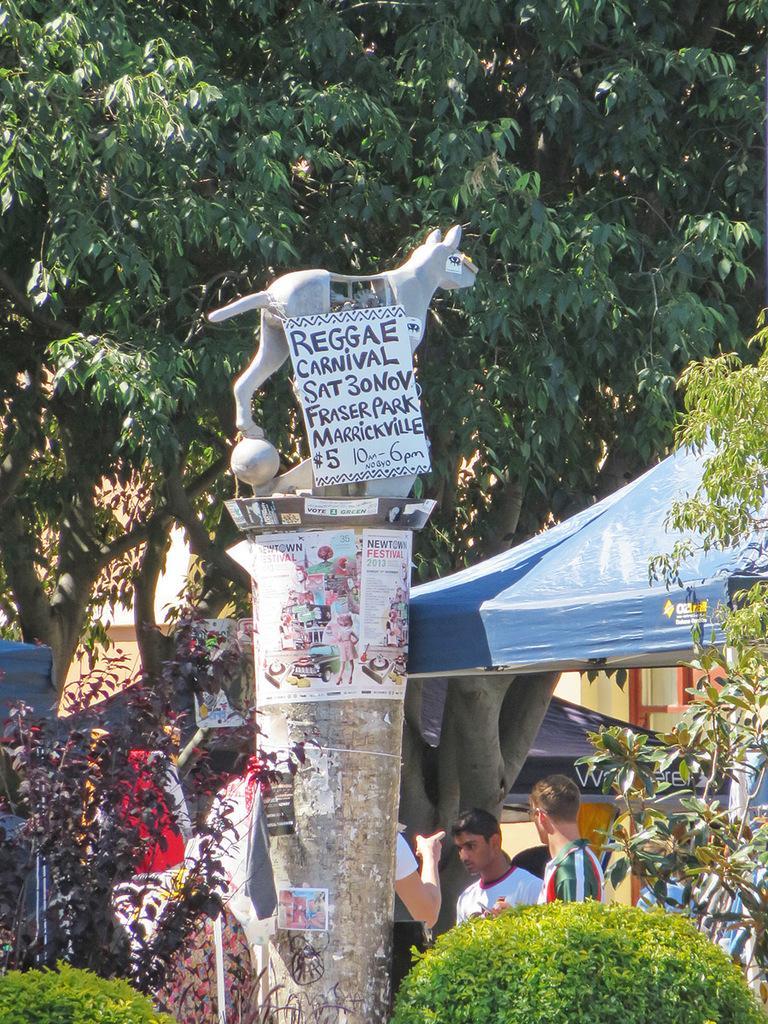Could you give a brief overview of what you see in this image? In this picture I can see there is a pillar and there is something placed on the pillar and there is a board attached to it. I can see there is a tent and there are few people standing here and there are plants, trees in the backdrop. 